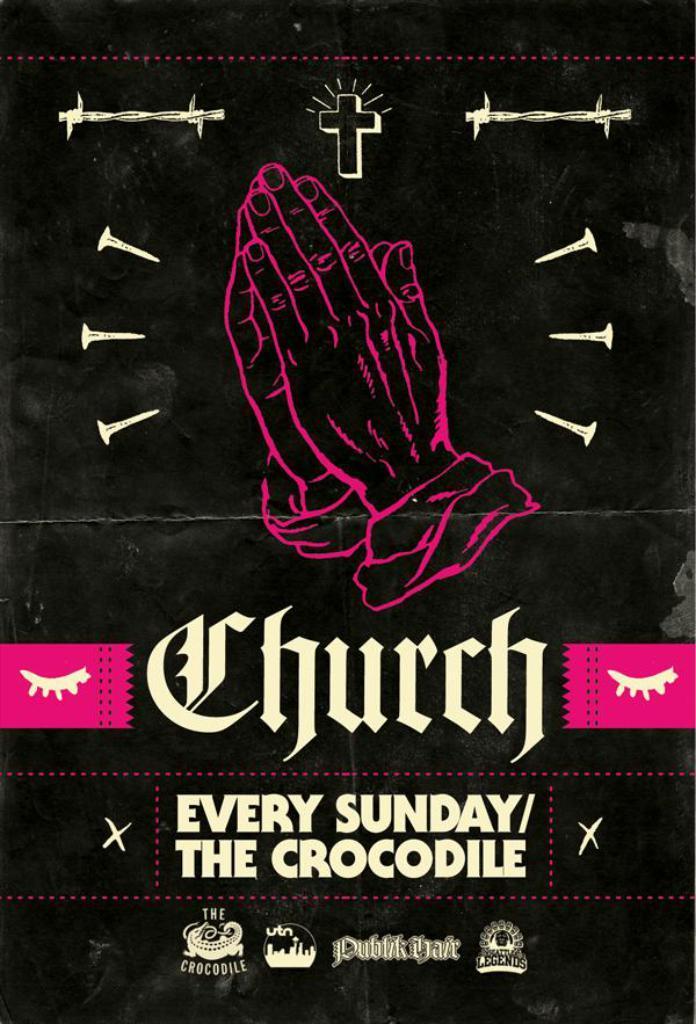How would you summarize this image in a sentence or two? In this picture we can see a person hands, symbols and some text on it. 